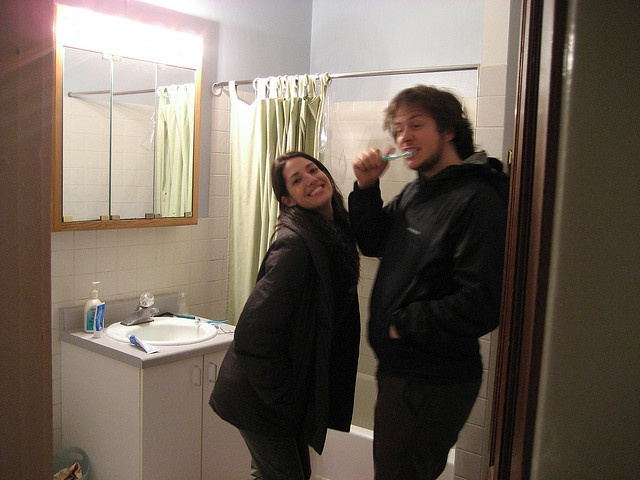Describe the objects in this image and their specific colors. I can see people in maroon, black, and gray tones, people in maroon, black, brown, and gray tones, sink in maroon, ivory, lightgray, and darkgray tones, and toothbrush in maroon, gray, and darkgray tones in this image. 